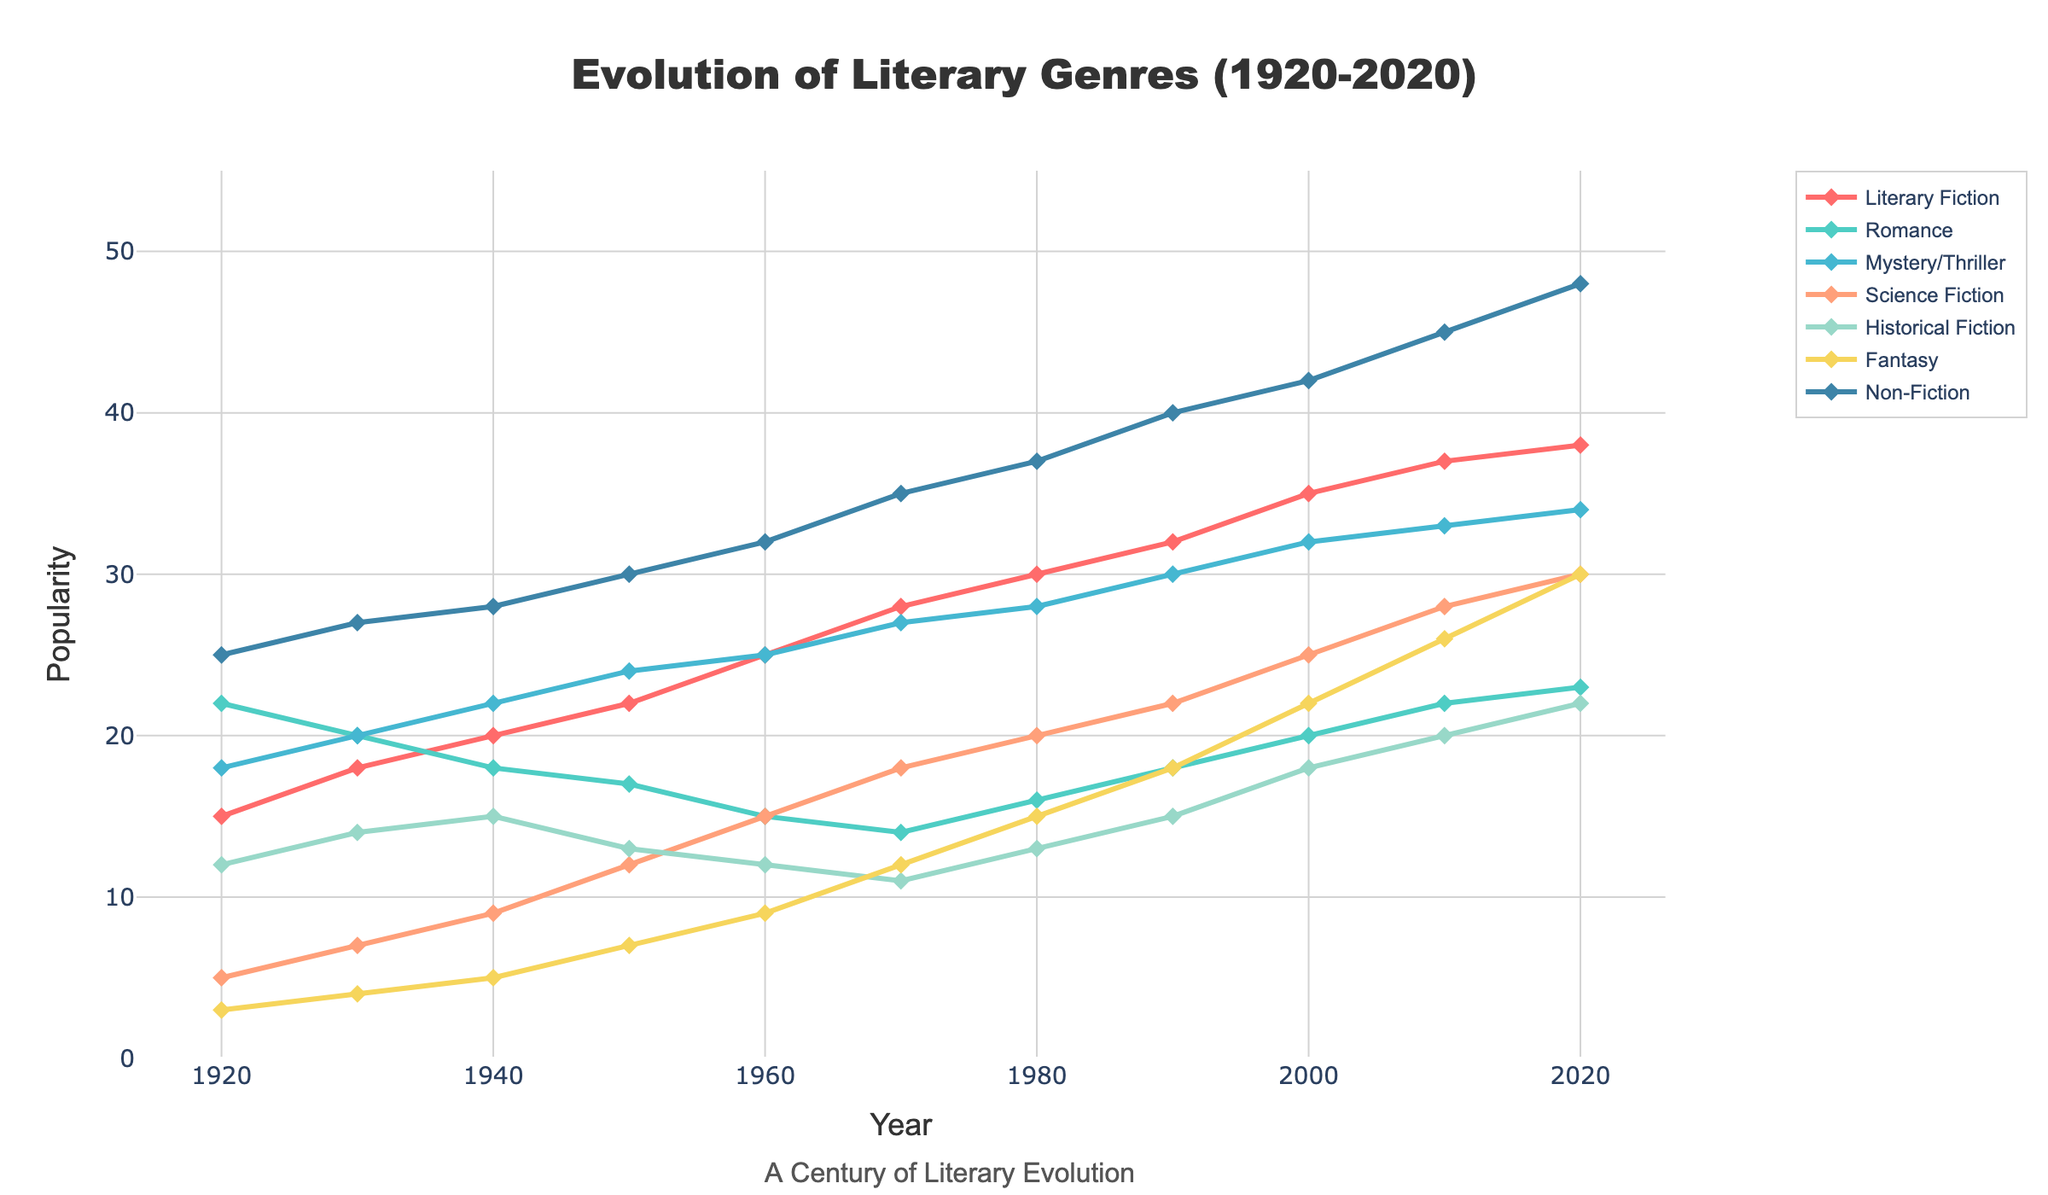what trend do you notice in the popularity of Science Fiction from 1920 to 2020? The line for Science Fiction shows a continuous increase in popularity over the century. Beginning at 5 in 1920 and rising steadily to 30 by 2020.
Answer: Continuous increase How does the increase in Non-Fiction from 1930 to 1950 compare to the increase from 1950 to 2020? From 1930 to 1950, Non-Fiction increased from 27 to 30, a change of 3 units. From 1950 to 2020, it increased from 30 to 48, a change of 18 units. The second period shows a much larger increase.
Answer: More increase in second period Which genre experienced the smallest change in popularity from 1920 to 2020? By examining the end and starting points of each genre, Fantasy starts at 3 in 1920 and ends at 30 in 2020, making its change 27 units. This is the smallest change compared to others, with Romance and Historical Fiction also showing significant jumps.
Answer: Fantasy During which decade did Romance see the largest decline in popularity? Between 1950 and 1960, Romance dropped from 17 to 15, which is the largest single drop observed.
Answer: 1950 to 1960 What is the combined popularity of Literary Fiction and Non-Fiction in 2020? In 2020, Literary Fiction has a popularity of 38 and Non-Fiction has 48. The combined popularity is 38 + 48 = 86.
Answer: 86 Compare the popularity of Mystery/Thriller and Historical Fiction in 2020. Which is more popular and by how much? In 2020, Mystery/Thriller stands at 34, and Historical Fiction at 22. Mystery/Thriller is more popular by 34 - 22 = 12 units.
Answer: Mystery/Thriller by 12 units If we average the popularity of Fantasy over each decade, what will be its average popularity? Fantasy's values are [3, 4, 5, 7, 9, 12, 15, 18, 22, 26, 30]. Summing these gives 151. Dividing by 11 (number of decades) gives an average of 151/11 ≈ 13.73.
Answer: 13.73 Which genre surpassed the 20 popularity mark first, and in which decade did this happen? By examining trends, Romance reached 22 in 1920, the first genre to surpass the 20 mark.
Answer: Romance in 1920 How does the rise in popularity of Fantasy from 1970 to 2000 compare to the rise in Historical Fiction in the same period? Fantasy rose from 12 in 1970 to 22 in 2000, a change of 10 units. Historical Fiction went from 11 in 1970 to 18 in 2000, a change of 7 units. Fantasy saw a larger rise.
Answer: Fantasy by 3 units more Which year saw the inflection point where the popularity of Science Fiction started increasing more rapidly? Examining the plot, Science Fiction's popularity change accelerated significantly after 1950, moving from a modest rise to a steeper climb.
Answer: 1950 